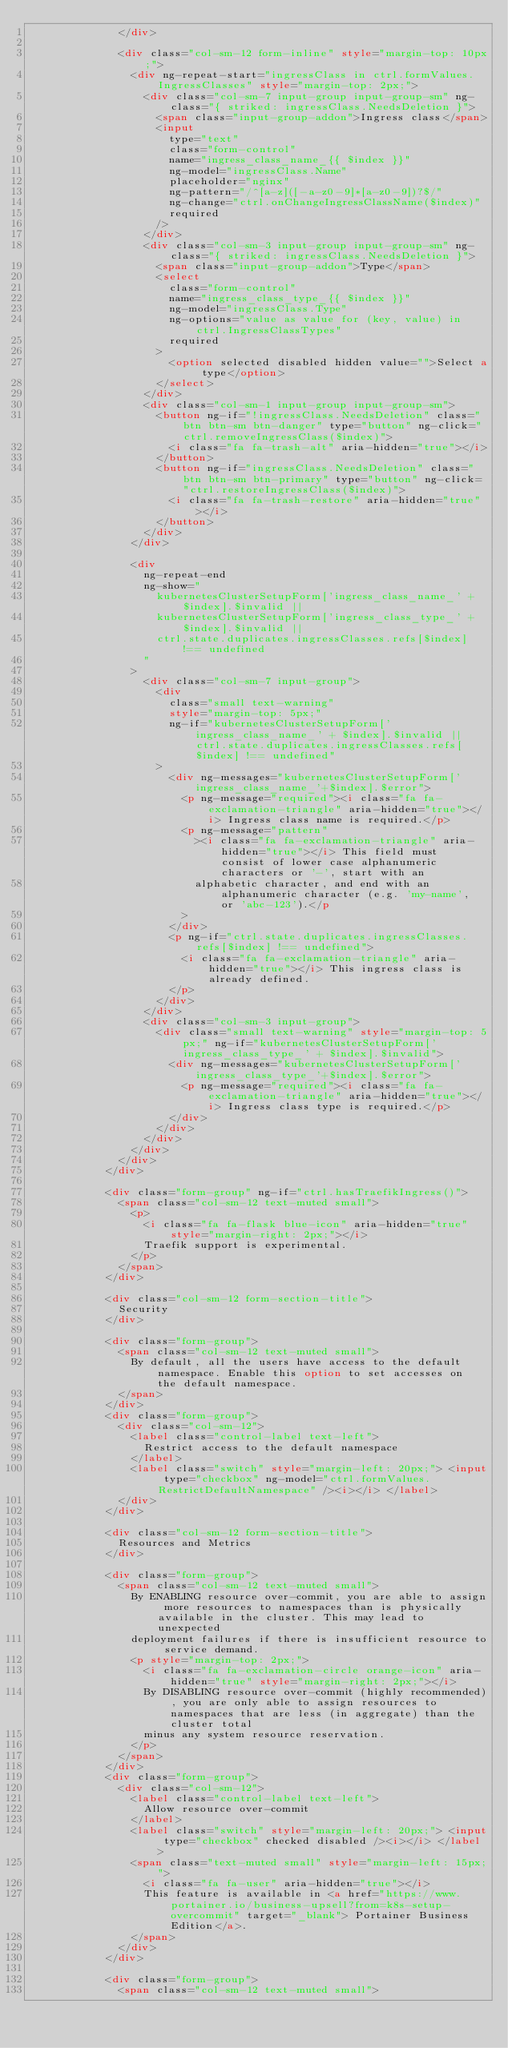<code> <loc_0><loc_0><loc_500><loc_500><_HTML_>              </div>

              <div class="col-sm-12 form-inline" style="margin-top: 10px;">
                <div ng-repeat-start="ingressClass in ctrl.formValues.IngressClasses" style="margin-top: 2px;">
                  <div class="col-sm-7 input-group input-group-sm" ng-class="{ striked: ingressClass.NeedsDeletion }">
                    <span class="input-group-addon">Ingress class</span>
                    <input
                      type="text"
                      class="form-control"
                      name="ingress_class_name_{{ $index }}"
                      ng-model="ingressClass.Name"
                      placeholder="nginx"
                      ng-pattern="/^[a-z]([-a-z0-9]*[a-z0-9])?$/"
                      ng-change="ctrl.onChangeIngressClassName($index)"
                      required
                    />
                  </div>
                  <div class="col-sm-3 input-group input-group-sm" ng-class="{ striked: ingressClass.NeedsDeletion }">
                    <span class="input-group-addon">Type</span>
                    <select
                      class="form-control"
                      name="ingress_class_type_{{ $index }}"
                      ng-model="ingressClass.Type"
                      ng-options="value as value for (key, value) in ctrl.IngressClassTypes"
                      required
                    >
                      <option selected disabled hidden value="">Select a type</option>
                    </select>
                  </div>
                  <div class="col-sm-1 input-group input-group-sm">
                    <button ng-if="!ingressClass.NeedsDeletion" class="btn btn-sm btn-danger" type="button" ng-click="ctrl.removeIngressClass($index)">
                      <i class="fa fa-trash-alt" aria-hidden="true"></i>
                    </button>
                    <button ng-if="ingressClass.NeedsDeletion" class="btn btn-sm btn-primary" type="button" ng-click="ctrl.restoreIngressClass($index)">
                      <i class="fa fa-trash-restore" aria-hidden="true"></i>
                    </button>
                  </div>
                </div>

                <div
                  ng-repeat-end
                  ng-show="
                    kubernetesClusterSetupForm['ingress_class_name_' + $index].$invalid ||
                    kubernetesClusterSetupForm['ingress_class_type_' + $index].$invalid ||
                    ctrl.state.duplicates.ingressClasses.refs[$index] !== undefined
                  "
                >
                  <div class="col-sm-7 input-group">
                    <div
                      class="small text-warning"
                      style="margin-top: 5px;"
                      ng-if="kubernetesClusterSetupForm['ingress_class_name_' + $index].$invalid || ctrl.state.duplicates.ingressClasses.refs[$index] !== undefined"
                    >
                      <div ng-messages="kubernetesClusterSetupForm['ingress_class_name_'+$index].$error">
                        <p ng-message="required"><i class="fa fa-exclamation-triangle" aria-hidden="true"></i> Ingress class name is required.</p>
                        <p ng-message="pattern"
                          ><i class="fa fa-exclamation-triangle" aria-hidden="true"></i> This field must consist of lower case alphanumeric characters or '-', start with an
                          alphabetic character, and end with an alphanumeric character (e.g. 'my-name', or 'abc-123').</p
                        >
                      </div>
                      <p ng-if="ctrl.state.duplicates.ingressClasses.refs[$index] !== undefined">
                        <i class="fa fa-exclamation-triangle" aria-hidden="true"></i> This ingress class is already defined.
                      </p>
                    </div>
                  </div>
                  <div class="col-sm-3 input-group">
                    <div class="small text-warning" style="margin-top: 5px;" ng-if="kubernetesClusterSetupForm['ingress_class_type_' + $index].$invalid">
                      <div ng-messages="kubernetesClusterSetupForm['ingress_class_type_'+$index].$error">
                        <p ng-message="required"><i class="fa fa-exclamation-triangle" aria-hidden="true"></i> Ingress class type is required.</p>
                      </div>
                    </div>
                  </div>
                </div>
              </div>
            </div>

            <div class="form-group" ng-if="ctrl.hasTraefikIngress()">
              <span class="col-sm-12 text-muted small">
                <p>
                  <i class="fa fa-flask blue-icon" aria-hidden="true" style="margin-right: 2px;"></i>
                  Traefik support is experimental.
                </p>
              </span>
            </div>

            <div class="col-sm-12 form-section-title">
              Security
            </div>

            <div class="form-group">
              <span class="col-sm-12 text-muted small">
                By default, all the users have access to the default namespace. Enable this option to set accesses on the default namespace.
              </span>
            </div>
            <div class="form-group">
              <div class="col-sm-12">
                <label class="control-label text-left">
                  Restrict access to the default namespace
                </label>
                <label class="switch" style="margin-left: 20px;"> <input type="checkbox" ng-model="ctrl.formValues.RestrictDefaultNamespace" /><i></i> </label>
              </div>
            </div>

            <div class="col-sm-12 form-section-title">
              Resources and Metrics
            </div>

            <div class="form-group">
              <span class="col-sm-12 text-muted small">
                By ENABLING resource over-commit, you are able to assign more resources to namespaces than is physically available in the cluster. This may lead to unexpected
                deployment failures if there is insufficient resource to service demand.
                <p style="margin-top: 2px;">
                  <i class="fa fa-exclamation-circle orange-icon" aria-hidden="true" style="margin-right: 2px;"></i>
                  By DISABLING resource over-commit (highly recommended), you are only able to assign resources to namespaces that are less (in aggregate) than the cluster total
                  minus any system resource reservation.
                </p>
              </span>
            </div>
            <div class="form-group">
              <div class="col-sm-12">
                <label class="control-label text-left">
                  Allow resource over-commit
                </label>
                <label class="switch" style="margin-left: 20px;"> <input type="checkbox" checked disabled /><i></i> </label>
                <span class="text-muted small" style="margin-left: 15px;">
                  <i class="fa fa-user" aria-hidden="true"></i>
                  This feature is available in <a href="https://www.portainer.io/business-upsell?from=k8s-setup-overcommit" target="_blank"> Portainer Business Edition</a>.
                </span>
              </div>
            </div>

            <div class="form-group">
              <span class="col-sm-12 text-muted small"></code> 